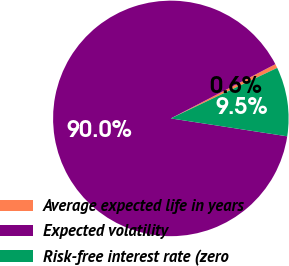Convert chart to OTSL. <chart><loc_0><loc_0><loc_500><loc_500><pie_chart><fcel>Average expected life in years<fcel>Expected volatility<fcel>Risk-free interest rate (zero<nl><fcel>0.56%<fcel>89.95%<fcel>9.49%<nl></chart> 